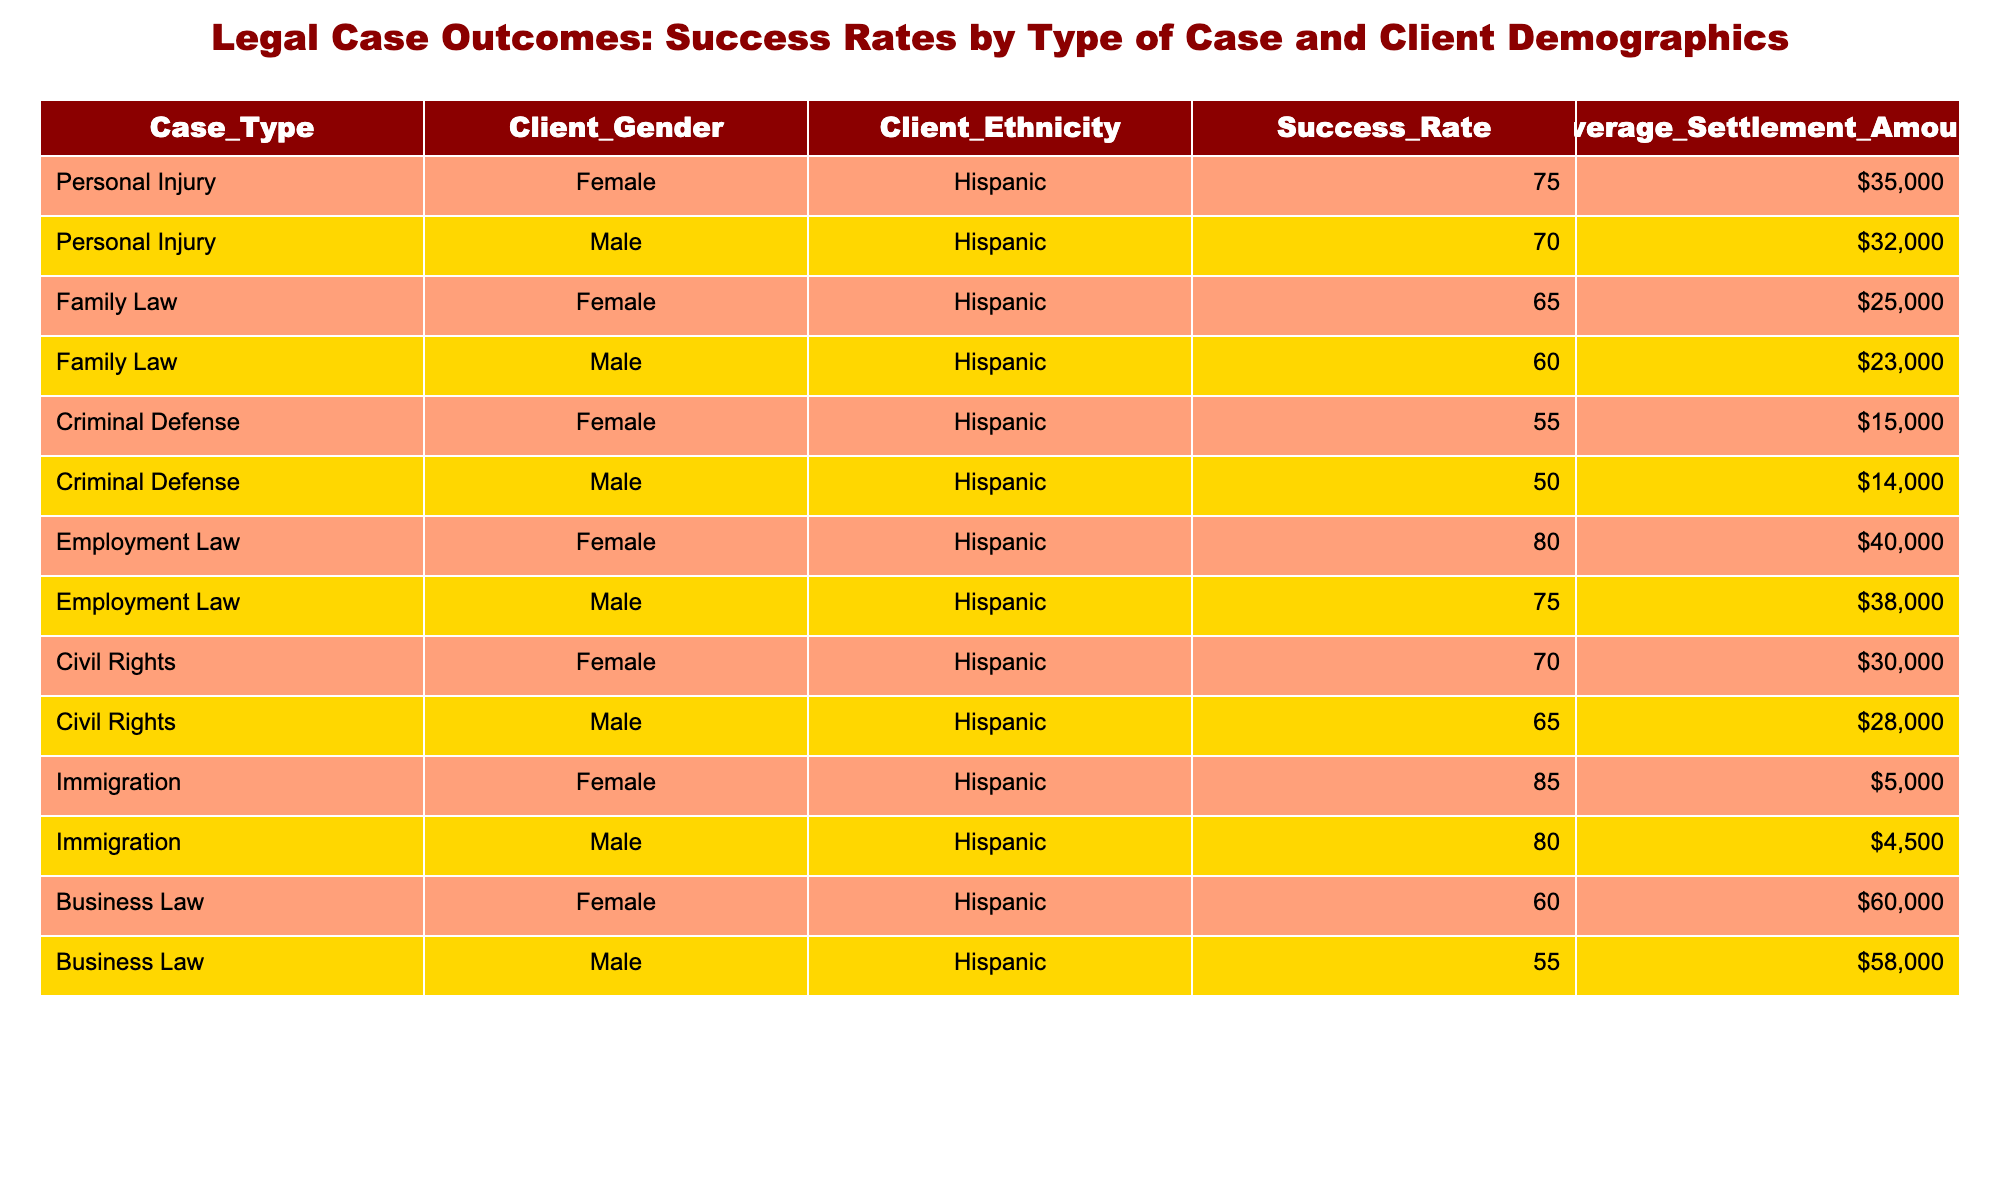What is the success rate for Female clients in Immigration cases? The table shows that the success rate for Female clients in Immigration cases is specified in the "Success Rate" column under "Immigration" and "Female". Looking closely, it states "85%".
Answer: 85% What is the average settlement amount for Male clients in Employment Law cases? By reviewing the table, for Male clients under "Employment Law," the average settlement amount can be found in the "Average Settlement Amount" column. It indicates "38,000".
Answer: $38,000 Are success rates for Personal Injury cases generally higher than for Criminal Defense cases? In the table, the success rates for Personal Injury (75% Female and 70% Male) are compared with Criminal Defense cases (55% Female and 50% Male). Both average out (calculated as (75% + 70%) / 2 = 72.5% for Personal Injury and (55% + 50%) / 2 = 52.5% for Criminal Defense). Therefore, yes, Personal Injury has a higher average success rate.
Answer: Yes What is the difference in success rates between Female and Male clients in Family Law cases? The success rates for Female clients in Family Law is 65% and for Male clients, it is 60%. The difference is calculated by subtracting the Male success rate from the Female success rate: 65% - 60% = 5%.
Answer: 5% What is the average success rate across all case types for Female clients? To calculate this, we need to look at the success rates of Female clients across all cases. They are: 75% (Personal Injury), 65% (Family Law), 55% (Criminal Defense), 80% (Employment Law), 70% (Civil Rights), and 85% (Immigration). Adding those gives 75 + 65 + 55 + 80 + 70 + 85 = 430. Dividing by the number of case types (6) gives 430 / 6 = 71.67%.
Answer: 71.67% Is the success rate in Business Law for Male clients lower than that for Female clients? Looking at the table, the success rate for Male clients in Business Law is 55% while for Female clients it is 60%. Since 55% is less than 60%, it confirms that Male clients have a lower success rate.
Answer: Yes 